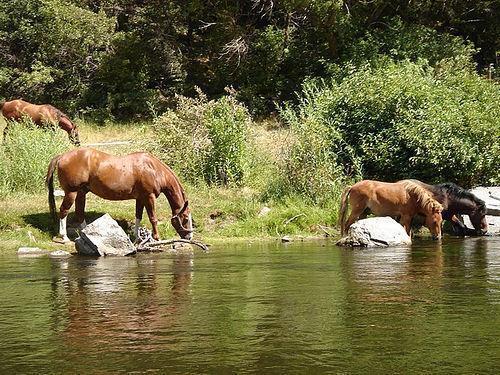How many horses?
Give a very brief answer. 4. 